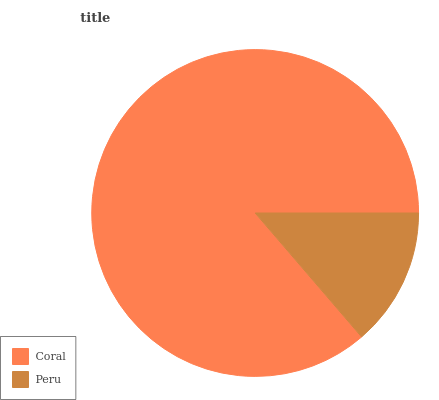Is Peru the minimum?
Answer yes or no. Yes. Is Coral the maximum?
Answer yes or no. Yes. Is Peru the maximum?
Answer yes or no. No. Is Coral greater than Peru?
Answer yes or no. Yes. Is Peru less than Coral?
Answer yes or no. Yes. Is Peru greater than Coral?
Answer yes or no. No. Is Coral less than Peru?
Answer yes or no. No. Is Coral the high median?
Answer yes or no. Yes. Is Peru the low median?
Answer yes or no. Yes. Is Peru the high median?
Answer yes or no. No. Is Coral the low median?
Answer yes or no. No. 